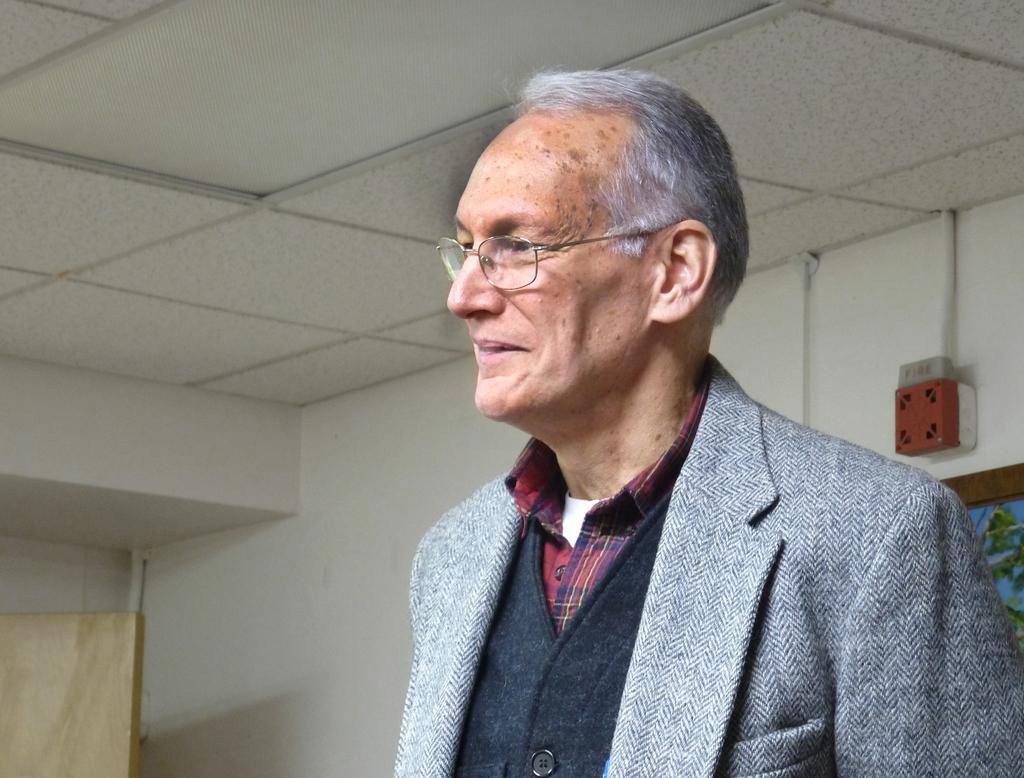In one or two sentences, can you explain what this image depicts? This picture is taken inside the room. In this image, on the right side, we can see a man wearing a gray color coat. On the right side, we can see a photo frame attached to a wall and a electrical instrument is also attached to a wall. In the left corner, we can see one edge of a door. At the top, we can see a roof. 